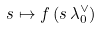Convert formula to latex. <formula><loc_0><loc_0><loc_500><loc_500>s \mapsto f \left ( s \, \lambda _ { 0 } ^ { \vee } \right )</formula> 